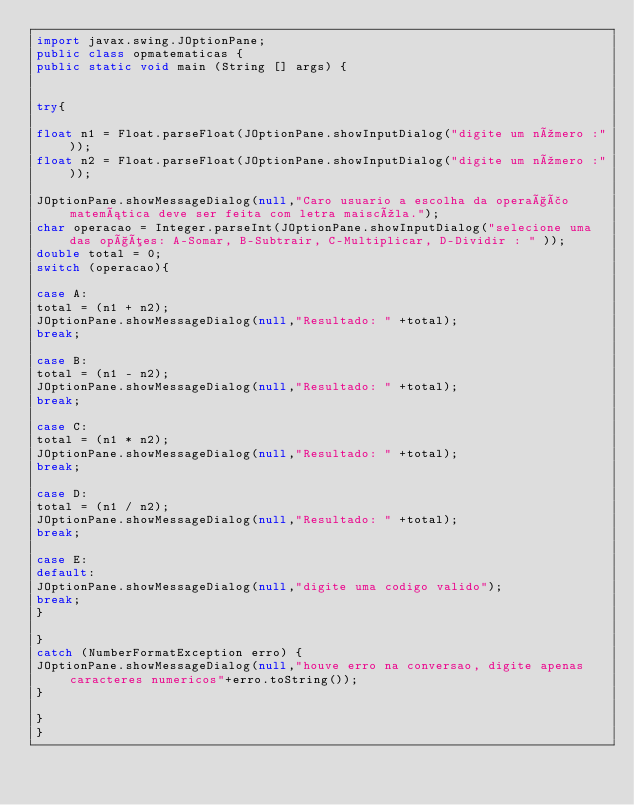Convert code to text. <code><loc_0><loc_0><loc_500><loc_500><_Java_>import javax.swing.JOptionPane;
public class opmatematicas {
public static void main (String [] args) {


try{

float n1 = Float.parseFloat(JOptionPane.showInputDialog("digite um número :"));
float n2 = Float.parseFloat(JOptionPane.showInputDialog("digite um número :"));

JOptionPane.showMessageDialog(null,"Caro usuario a escolha da operação matemática deve ser feita com letra maiscúla.");
char operacao = Integer.parseInt(JOptionPane.showInputDialog("selecione uma das opções: A-Somar, B-Subtrair, C-Multiplicar, D-Dividir : " ));
double total = 0;
switch (operacao){

case A:
total = (n1 + n2);
JOptionPane.showMessageDialog(null,"Resultado: " +total);
break;

case B:
total = (n1 - n2);
JOptionPane.showMessageDialog(null,"Resultado: " +total);
break;

case C:
total = (n1 * n2);
JOptionPane.showMessageDialog(null,"Resultado: " +total);
break;

case D:
total = (n1 / n2);
JOptionPane.showMessageDialog(null,"Resultado: " +total);
break;

case E:
default:
JOptionPane.showMessageDialog(null,"digite uma codigo valido");
break;
}

}
catch (NumberFormatException erro) {
JOptionPane.showMessageDialog(null,"houve erro na conversao, digite apenas caracteres numericos"+erro.toString());
}

}
}
</code> 